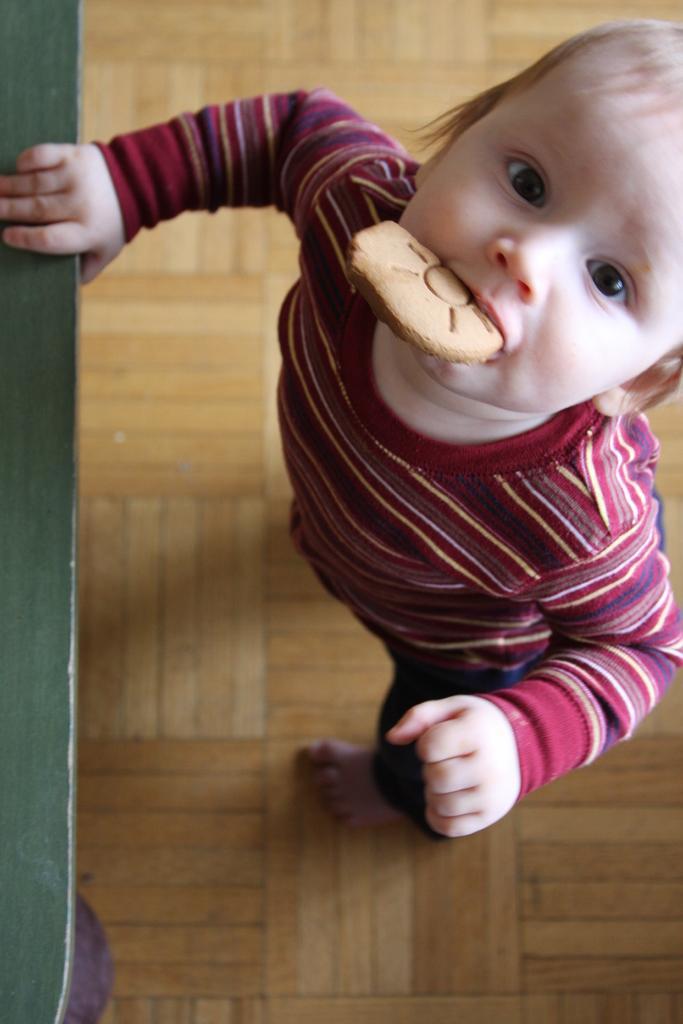Could you give a brief overview of what you see in this image? On the right side, there is a child having a biscuit in the mouth, standing on a floor and holding a green color object with a hand. And the background is brown in color. 